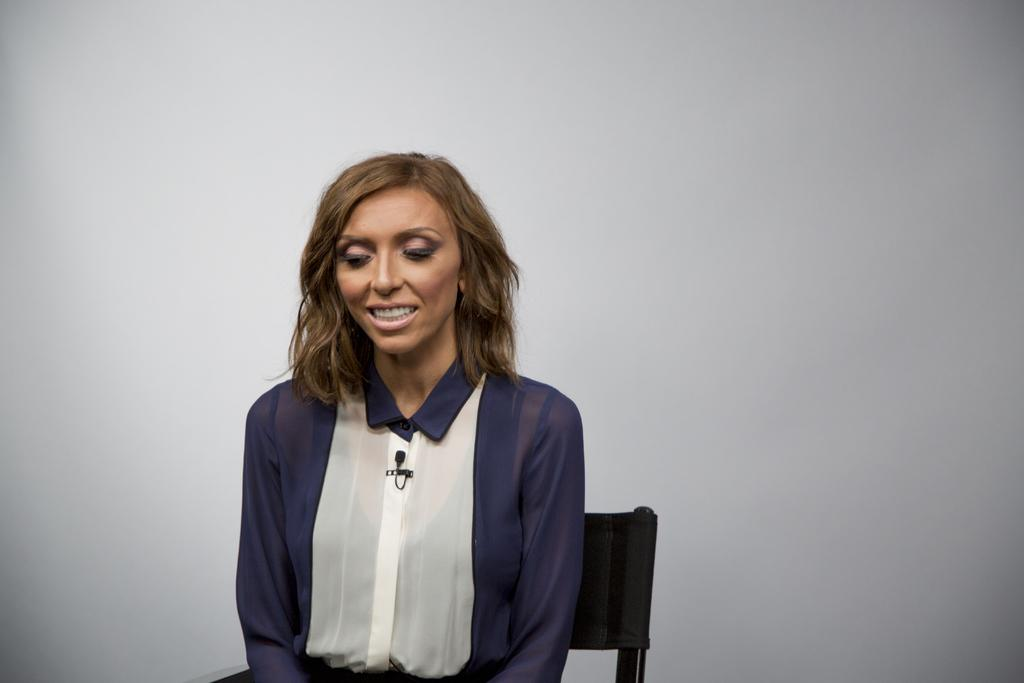Who is the main subject in the image? There is a woman in the image. What is the woman doing in the image? The woman is sitting on a chair. What can be seen in the background of the image? There is a white surface in the background of the image. What shape is the calendar on the woman's desk in the image? There is no calendar present in the image, so we cannot determine its shape. 